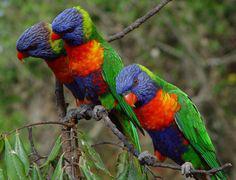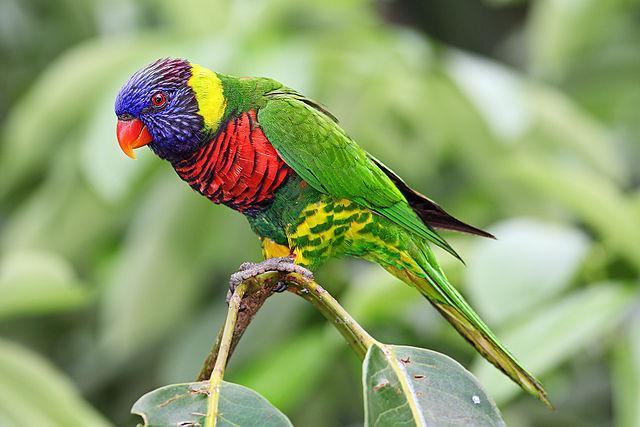The first image is the image on the left, the second image is the image on the right. Assess this claim about the two images: "Four colorful birds are perched outside.". Correct or not? Answer yes or no. Yes. The first image is the image on the left, the second image is the image on the right. Examine the images to the left and right. Is the description "Left image contains three parrots, and right image contains one left-facing parrot." accurate? Answer yes or no. Yes. 